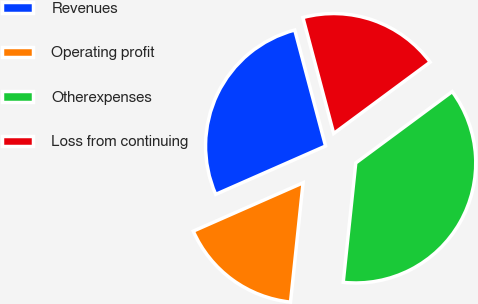Convert chart. <chart><loc_0><loc_0><loc_500><loc_500><pie_chart><fcel>Revenues<fcel>Operating profit<fcel>Otherexpenses<fcel>Loss from continuing<nl><fcel>27.47%<fcel>16.73%<fcel>36.81%<fcel>18.99%<nl></chart> 